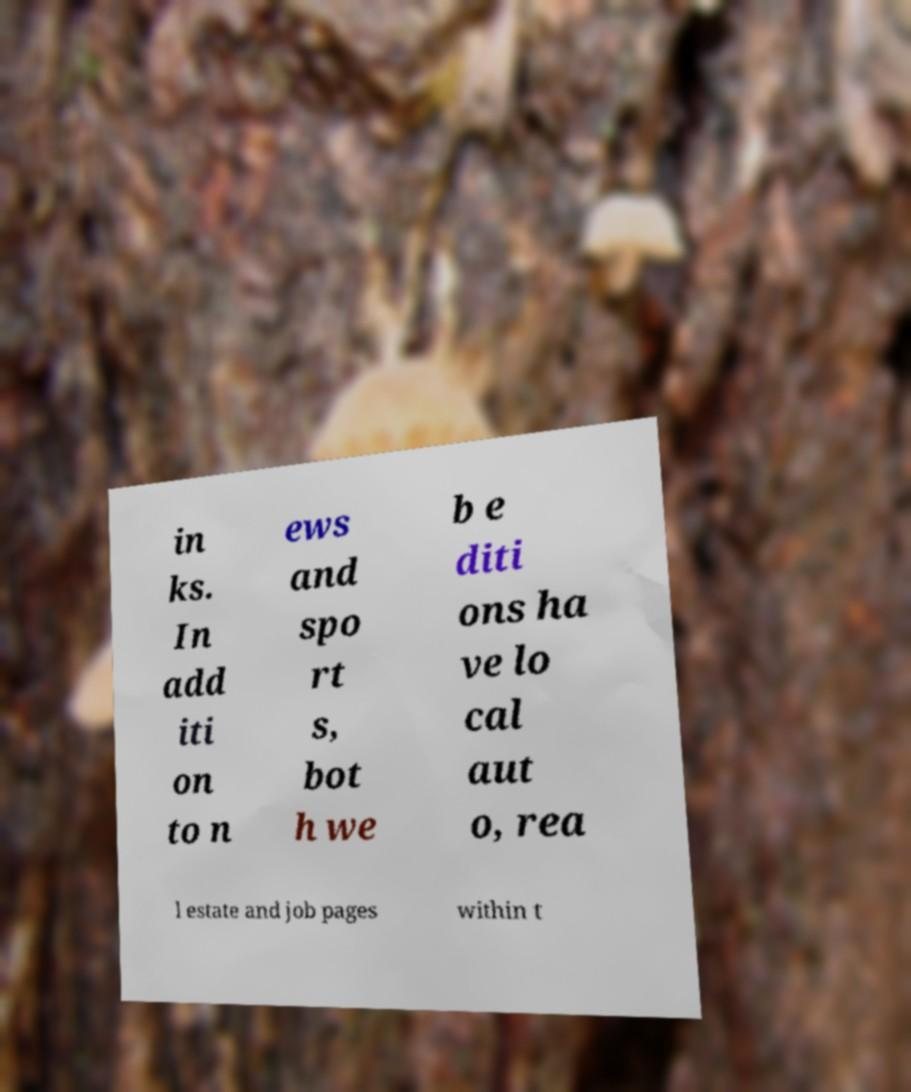Can you accurately transcribe the text from the provided image for me? in ks. In add iti on to n ews and spo rt s, bot h we b e diti ons ha ve lo cal aut o, rea l estate and job pages within t 